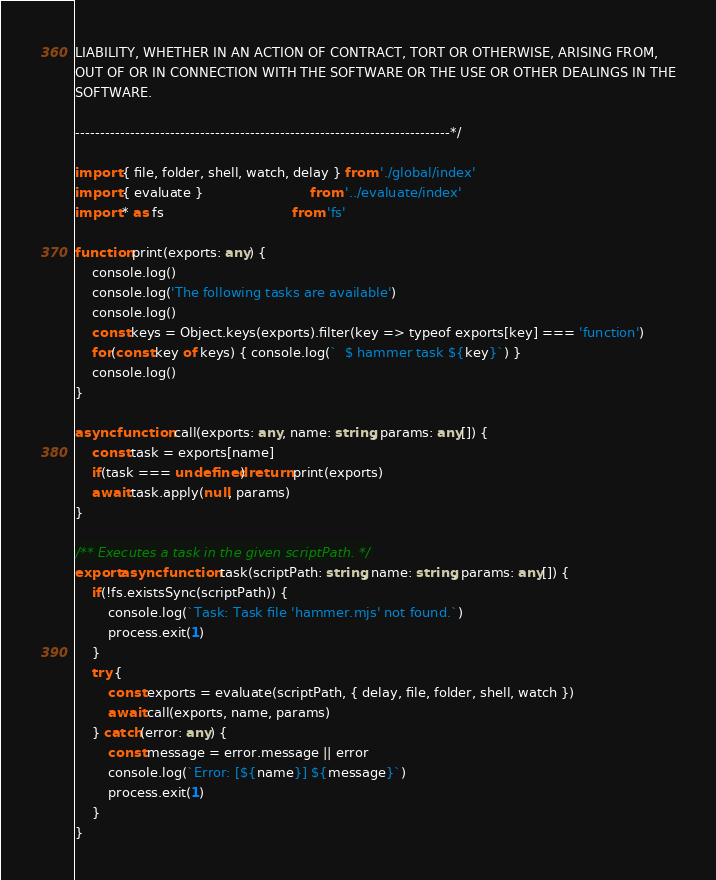Convert code to text. <code><loc_0><loc_0><loc_500><loc_500><_TypeScript_>LIABILITY, WHETHER IN AN ACTION OF CONTRACT, TORT OR OTHERWISE, ARISING FROM,
OUT OF OR IN CONNECTION WITH THE SOFTWARE OR THE USE OR OTHER DEALINGS IN THE
SOFTWARE.

---------------------------------------------------------------------------*/

import { file, folder, shell, watch, delay } from './global/index'
import { evaluate }                          from '../evaluate/index'
import * as fs                               from 'fs'

function print(exports: any) {
    console.log()
    console.log('The following tasks are available')
    console.log()
    const keys = Object.keys(exports).filter(key => typeof exports[key] === 'function')
    for(const key of keys) { console.log(`  $ hammer task ${key}`) }
    console.log()
}

async function call(exports: any, name: string, params: any[]) {
    const task = exports[name]
    if(task === undefined) return print(exports)
    await task.apply(null, params)
}

/** Executes a task in the given scriptPath. */
export async function task(scriptPath: string, name: string, params: any[]) {
    if(!fs.existsSync(scriptPath)) {
        console.log(`Task: Task file 'hammer.mjs' not found.`)
        process.exit(1)
    }
    try {
        const exports = evaluate(scriptPath, { delay, file, folder, shell, watch })
        await call(exports, name, params)
    } catch(error: any) {
        const message = error.message || error
        console.log(`Error: [${name}] ${message}`)
        process.exit(1)
    }
}
</code> 